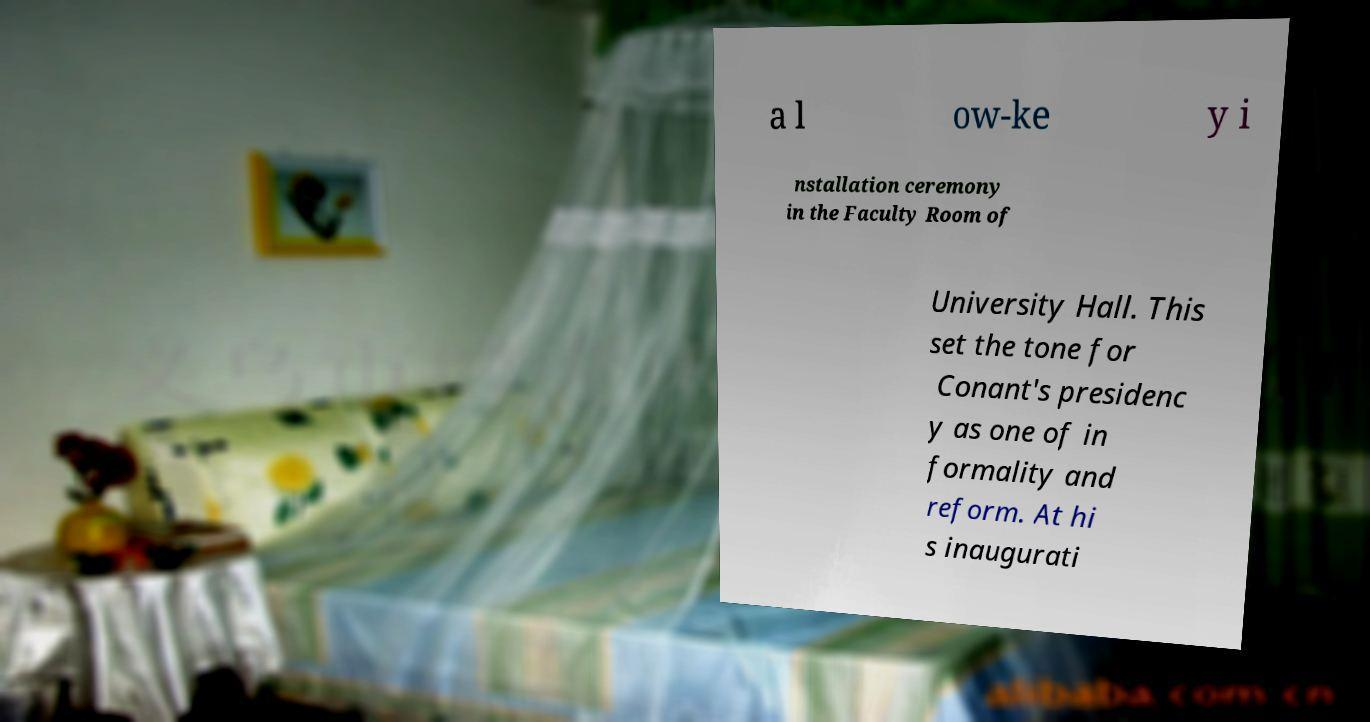Please read and relay the text visible in this image. What does it say? a l ow-ke y i nstallation ceremony in the Faculty Room of University Hall. This set the tone for Conant's presidenc y as one of in formality and reform. At hi s inaugurati 